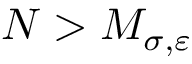Convert formula to latex. <formula><loc_0><loc_0><loc_500><loc_500>N > M _ { \sigma , \varepsilon }</formula> 